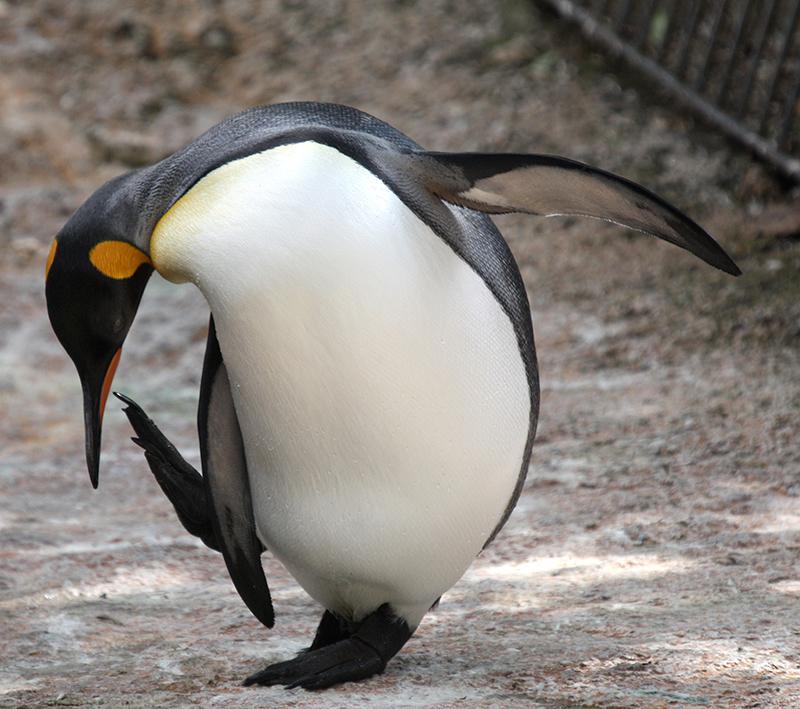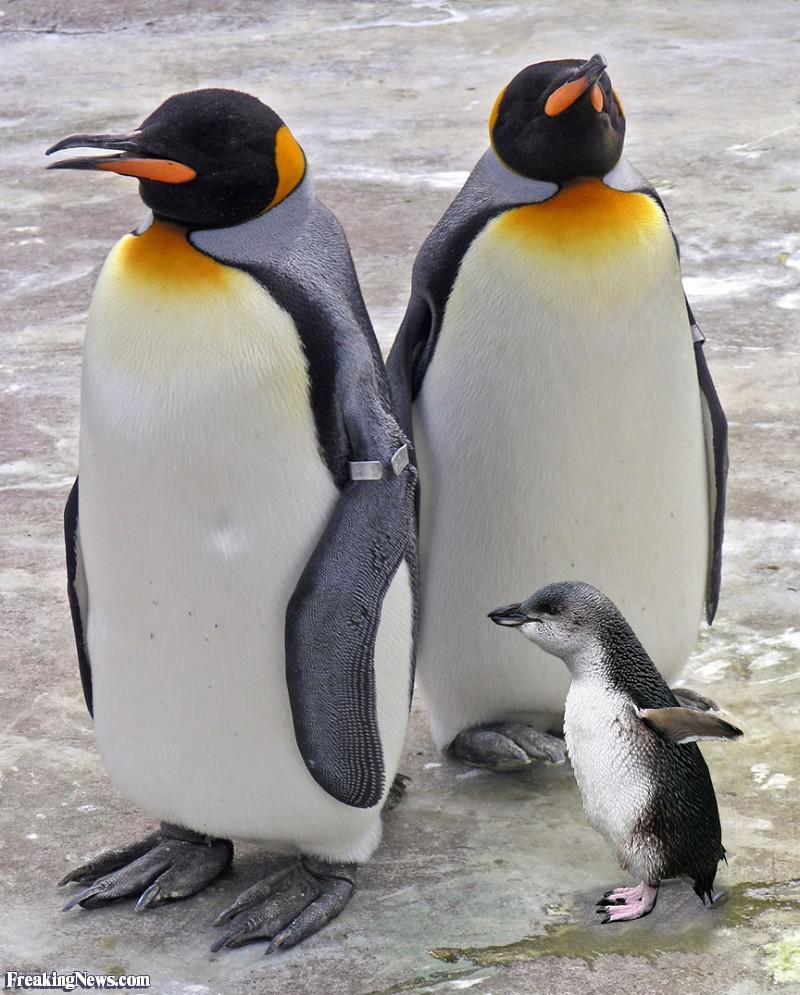The first image is the image on the left, the second image is the image on the right. Analyze the images presented: Is the assertion "There are two adult penguins standing with a baby penguin in the image on the right." valid? Answer yes or no. Yes. 